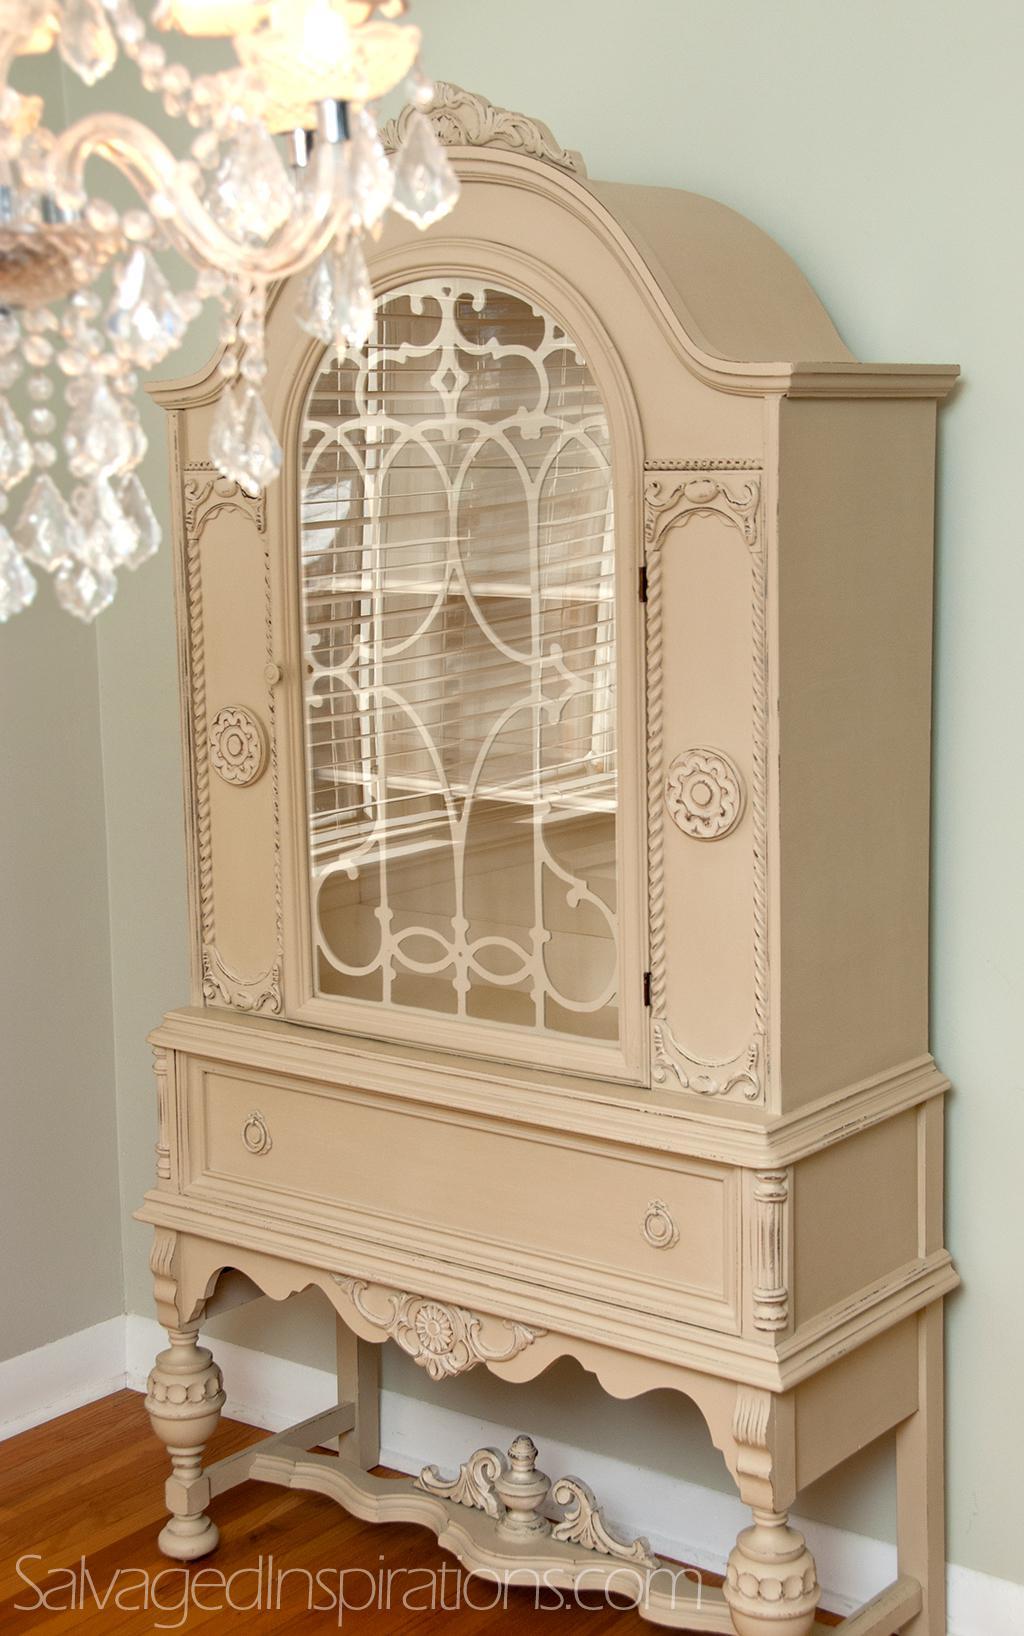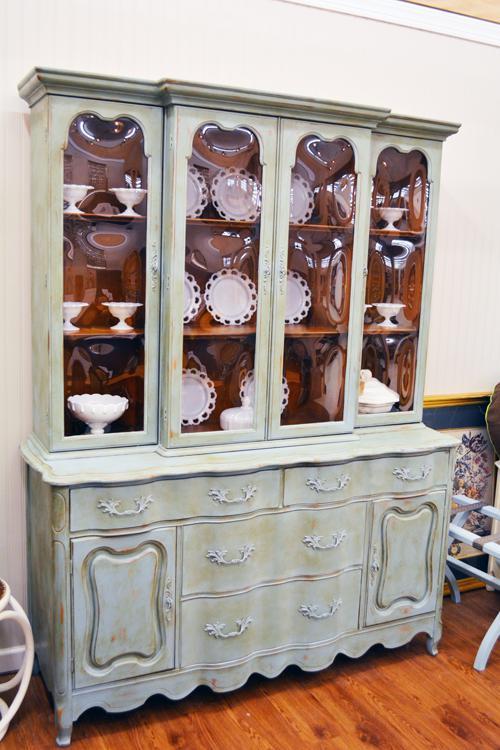The first image is the image on the left, the second image is the image on the right. For the images shown, is this caption "One flat topped wooden hutch has the same number of glass doors in its upper section as solid doors in its lower section and sits flush to the floor." true? Answer yes or no. No. The first image is the image on the left, the second image is the image on the right. Considering the images on both sides, is "An image features a cabinet with an arched top and at least two glass doors." valid? Answer yes or no. No. 